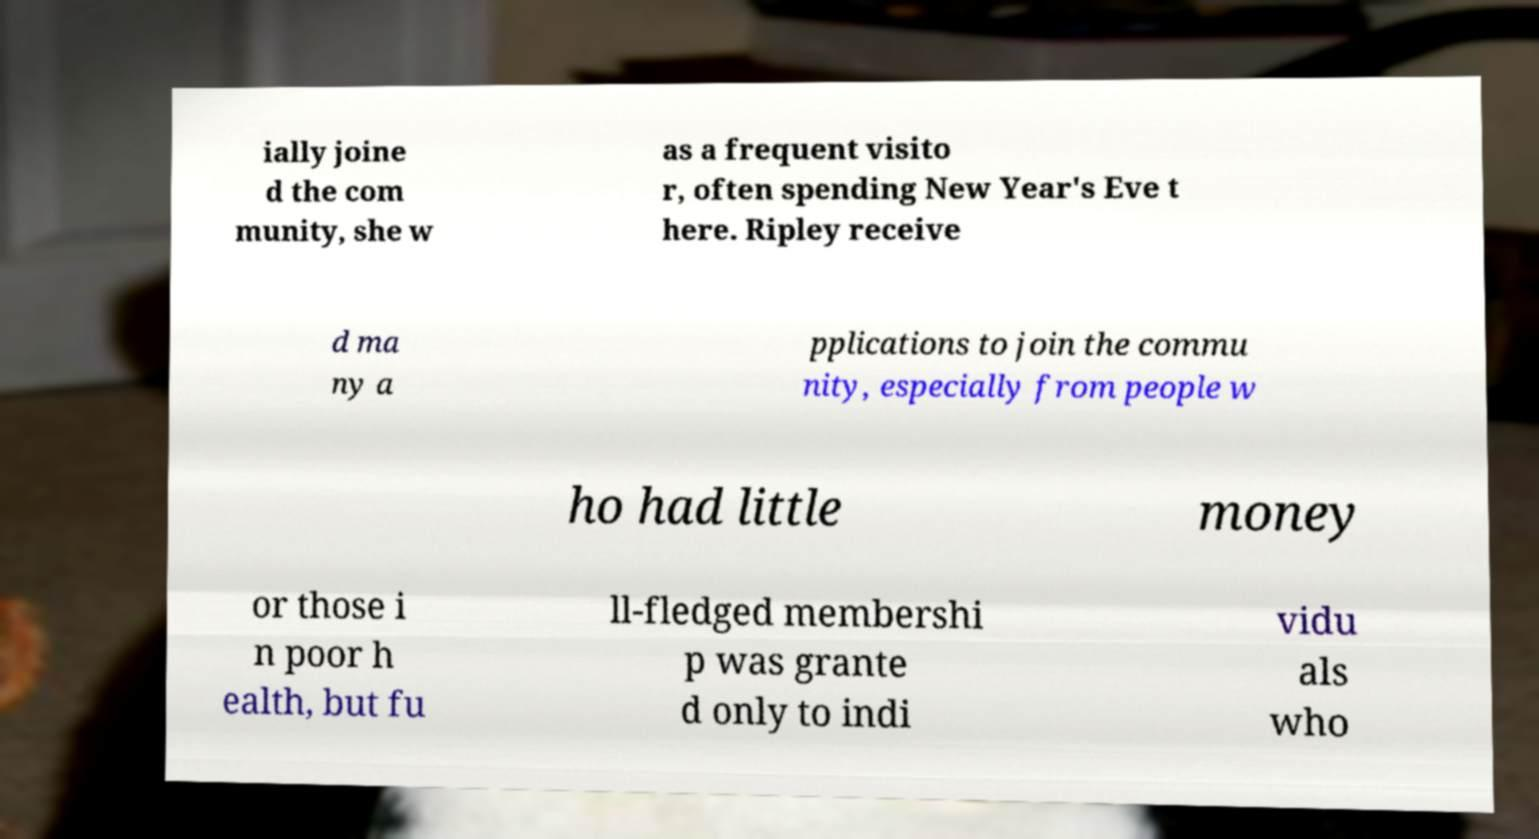What messages or text are displayed in this image? I need them in a readable, typed format. ially joine d the com munity, she w as a frequent visito r, often spending New Year's Eve t here. Ripley receive d ma ny a pplications to join the commu nity, especially from people w ho had little money or those i n poor h ealth, but fu ll-fledged membershi p was grante d only to indi vidu als who 